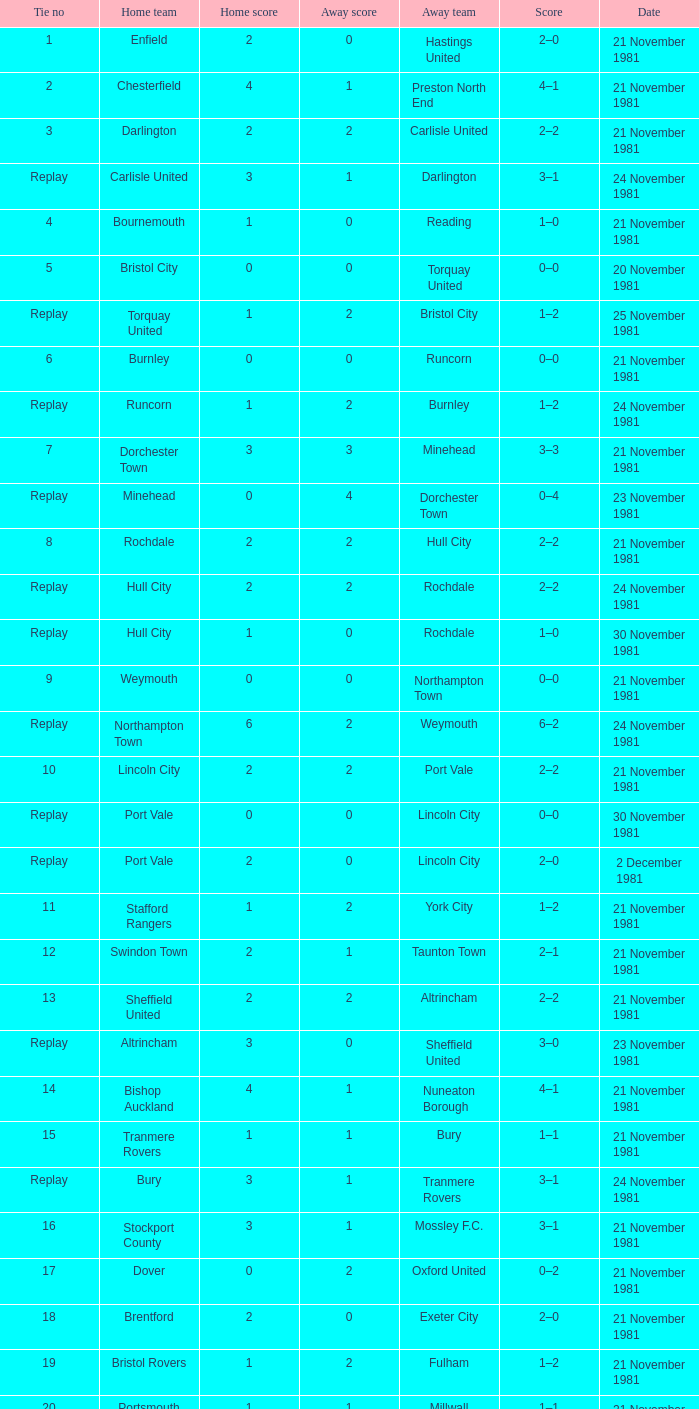On what date was tie number 4? 21 November 1981. 